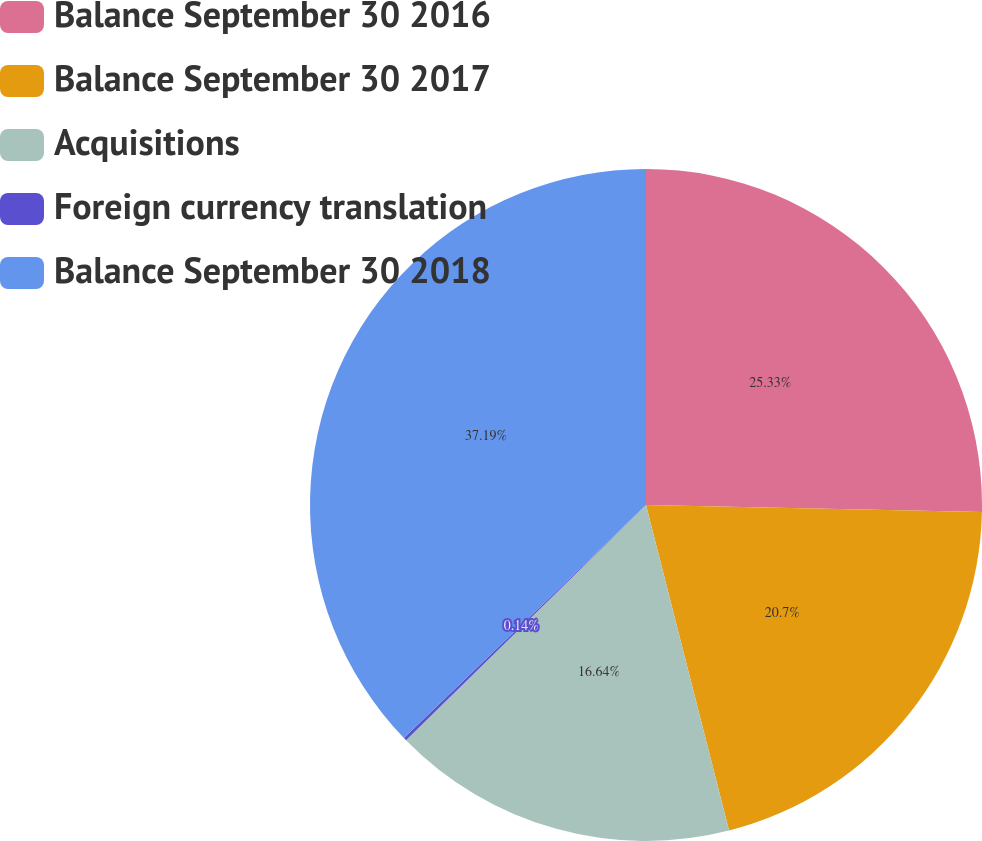Convert chart. <chart><loc_0><loc_0><loc_500><loc_500><pie_chart><fcel>Balance September 30 2016<fcel>Balance September 30 2017<fcel>Acquisitions<fcel>Foreign currency translation<fcel>Balance September 30 2018<nl><fcel>25.33%<fcel>20.7%<fcel>16.64%<fcel>0.14%<fcel>37.2%<nl></chart> 